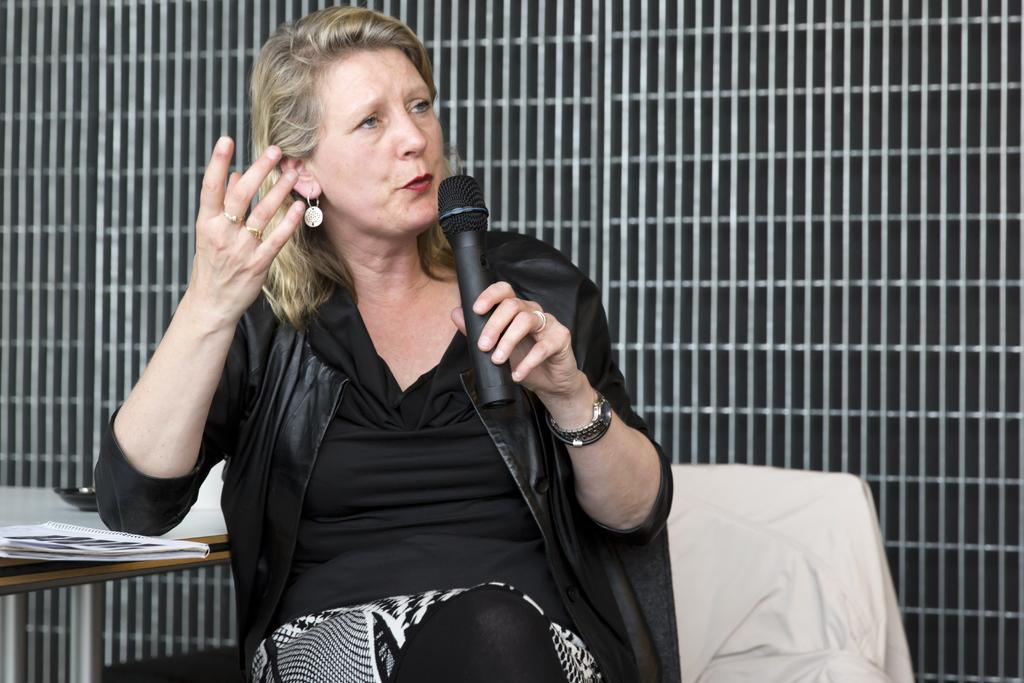Who is the main subject in the image? There is a woman in the image. What is the woman doing in the image? The woman is sitting on a chair and talking on the mic. What is the woman holding in her hand? The woman is holding a mic in her hand. What can be seen in the background of the image? There is a wall in the background of the image, with rods and papers on it. What type of celery is the woman eating in the image? There is no celery present in the image; the woman is holding a mic and talking. What color is the skirt the woman is wearing in the image? The woman is not wearing a skirt in the image; she is sitting on a chair and talking on the mic. 